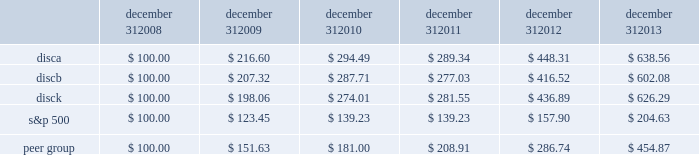Common stock from time to time through open market purchases or privately negotiated transactions at prevailing prices as permitted by securities laws and other legal requirements , and subject to stock price , business and market conditions and other factors .
We have been funding and expect to continue to fund stock repurchases through a combination of cash on hand and cash generated by operations .
In the future , we may also choose to fund our stock repurchase program under our revolving credit facility or future financing transactions .
There were no repurchases of our series a and b common stock during the three months ended december 31 , 2013 .
The company first announced its stock repurchase program on august 3 , 2010 .
Stock performance graph the following graph sets forth the cumulative total shareholder return on our series a common stock , series b common stock and series c common stock as compared with the cumulative total return of the companies listed in the standard and poor 2019s 500 stock index ( 201cs&p 500 index 201d ) and a peer group of companies comprised of cbs corporation class b common stock , scripps network interactive , inc. , time warner , inc. , twenty-first century fox , inc .
Class a common stock ( news corporation class a common stock prior to june 2013 ) , viacom , inc .
Class b common stock and the walt disney company .
The graph assumes $ 100 originally invested on december 31 , 2008 in each of our series a common stock , series b common stock and series c common stock , the s&p 500 index , and the stock of our peer group companies , including reinvestment of dividends , for the years ended december 31 , 2009 , 2010 , 2011 , 2012 and 2013 .
December 31 , december 31 , december 31 , december 31 , december 31 , december 31 .
Equity compensation plan information information regarding securities authorized for issuance under equity compensation plans will be set forth in our definitive proxy statement for our 2014 annual meeting of stockholders under the caption 201csecurities authorized for issuance under equity compensation plans , 201d which is incorporated herein by reference. .
What was the percentage cumulative total shareholder return on disca for the five year period ended december 21 , 2013? 
Computations: ((638.56 - 100) / 100)
Answer: 5.3856. Common stock from time to time through open market purchases or privately negotiated transactions at prevailing prices as permitted by securities laws and other legal requirements , and subject to stock price , business and market conditions and other factors .
We have been funding and expect to continue to fund stock repurchases through a combination of cash on hand and cash generated by operations .
In the future , we may also choose to fund our stock repurchase program under our revolving credit facility or future financing transactions .
There were no repurchases of our series a and b common stock during the three months ended december 31 , 2013 .
The company first announced its stock repurchase program on august 3 , 2010 .
Stock performance graph the following graph sets forth the cumulative total shareholder return on our series a common stock , series b common stock and series c common stock as compared with the cumulative total return of the companies listed in the standard and poor 2019s 500 stock index ( 201cs&p 500 index 201d ) and a peer group of companies comprised of cbs corporation class b common stock , scripps network interactive , inc. , time warner , inc. , twenty-first century fox , inc .
Class a common stock ( news corporation class a common stock prior to june 2013 ) , viacom , inc .
Class b common stock and the walt disney company .
The graph assumes $ 100 originally invested on december 31 , 2008 in each of our series a common stock , series b common stock and series c common stock , the s&p 500 index , and the stock of our peer group companies , including reinvestment of dividends , for the years ended december 31 , 2009 , 2010 , 2011 , 2012 and 2013 .
December 31 , december 31 , december 31 , december 31 , december 31 , december 31 .
Equity compensation plan information information regarding securities authorized for issuance under equity compensation plans will be set forth in our definitive proxy statement for our 2014 annual meeting of stockholders under the caption 201csecurities authorized for issuance under equity compensation plans , 201d which is incorporated herein by reference. .
What was the percentage cumulative total shareholder return on disca for the five year period ended december 21 , 2013? 
Computations: ((602.08 - 100) / 100)
Answer: 5.0208. 